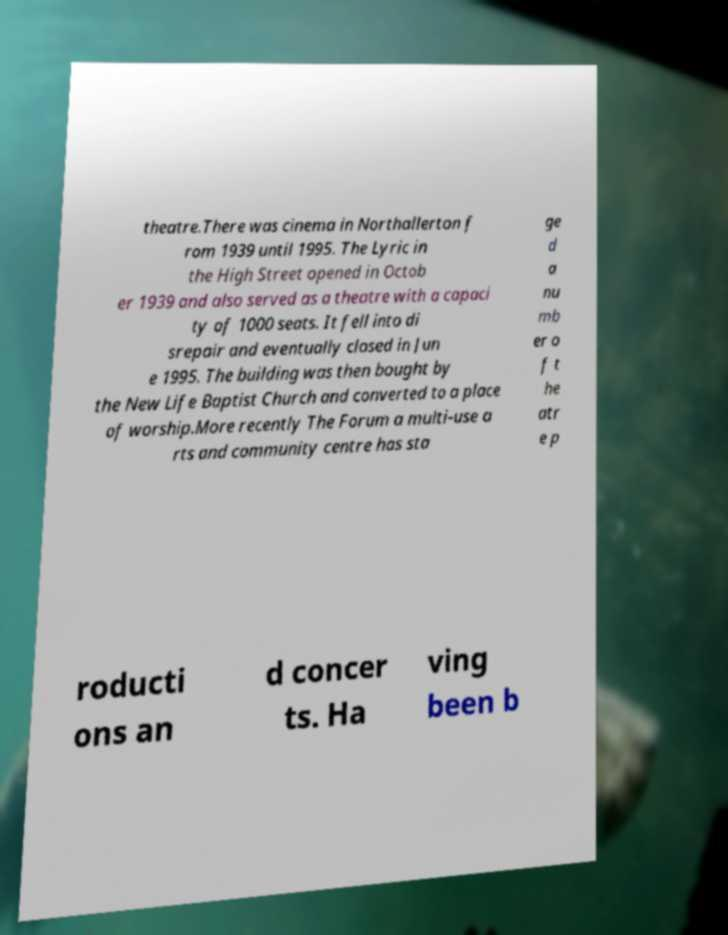What messages or text are displayed in this image? I need them in a readable, typed format. theatre.There was cinema in Northallerton f rom 1939 until 1995. The Lyric in the High Street opened in Octob er 1939 and also served as a theatre with a capaci ty of 1000 seats. It fell into di srepair and eventually closed in Jun e 1995. The building was then bought by the New Life Baptist Church and converted to a place of worship.More recently The Forum a multi-use a rts and community centre has sta ge d a nu mb er o f t he atr e p roducti ons an d concer ts. Ha ving been b 